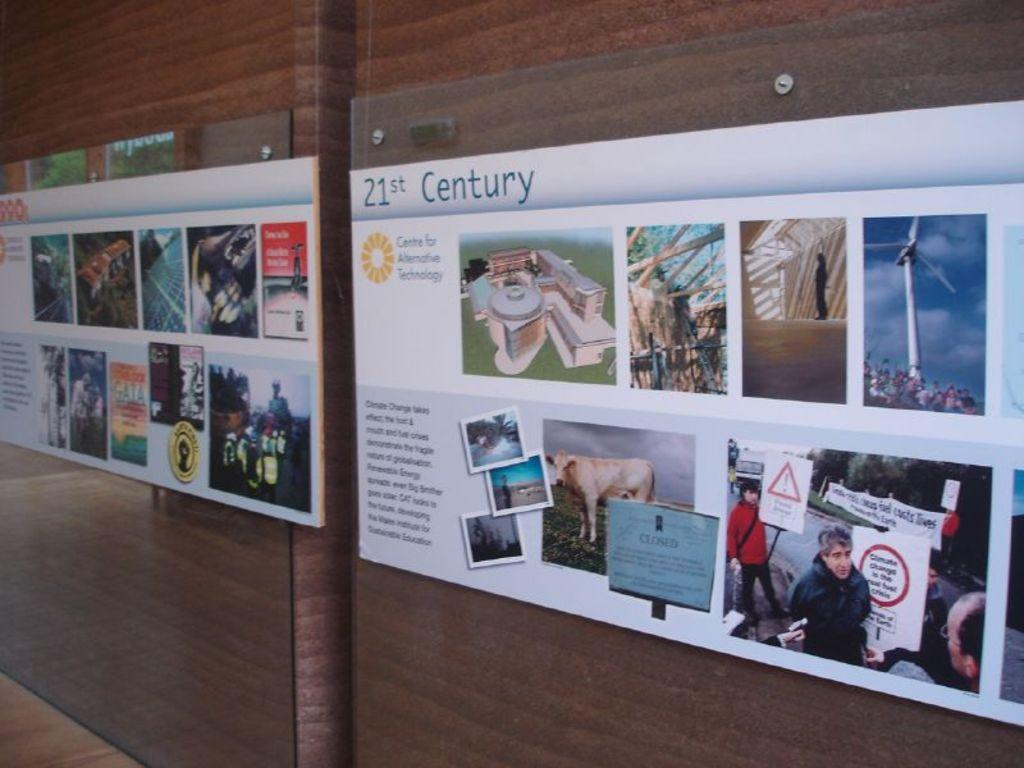<image>
Relay a brief, clear account of the picture shown. A poster titled 21st Century is attached to a wall and shows various photographs and images. 